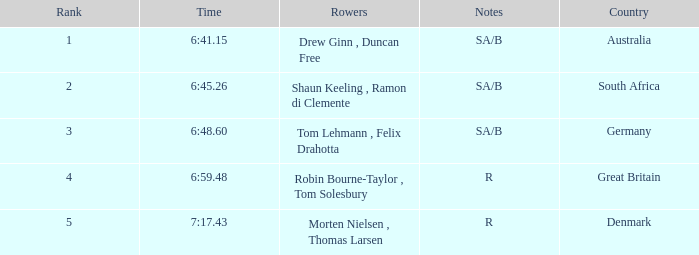What was the time for the rowers representing great britain? 6:59.48. 